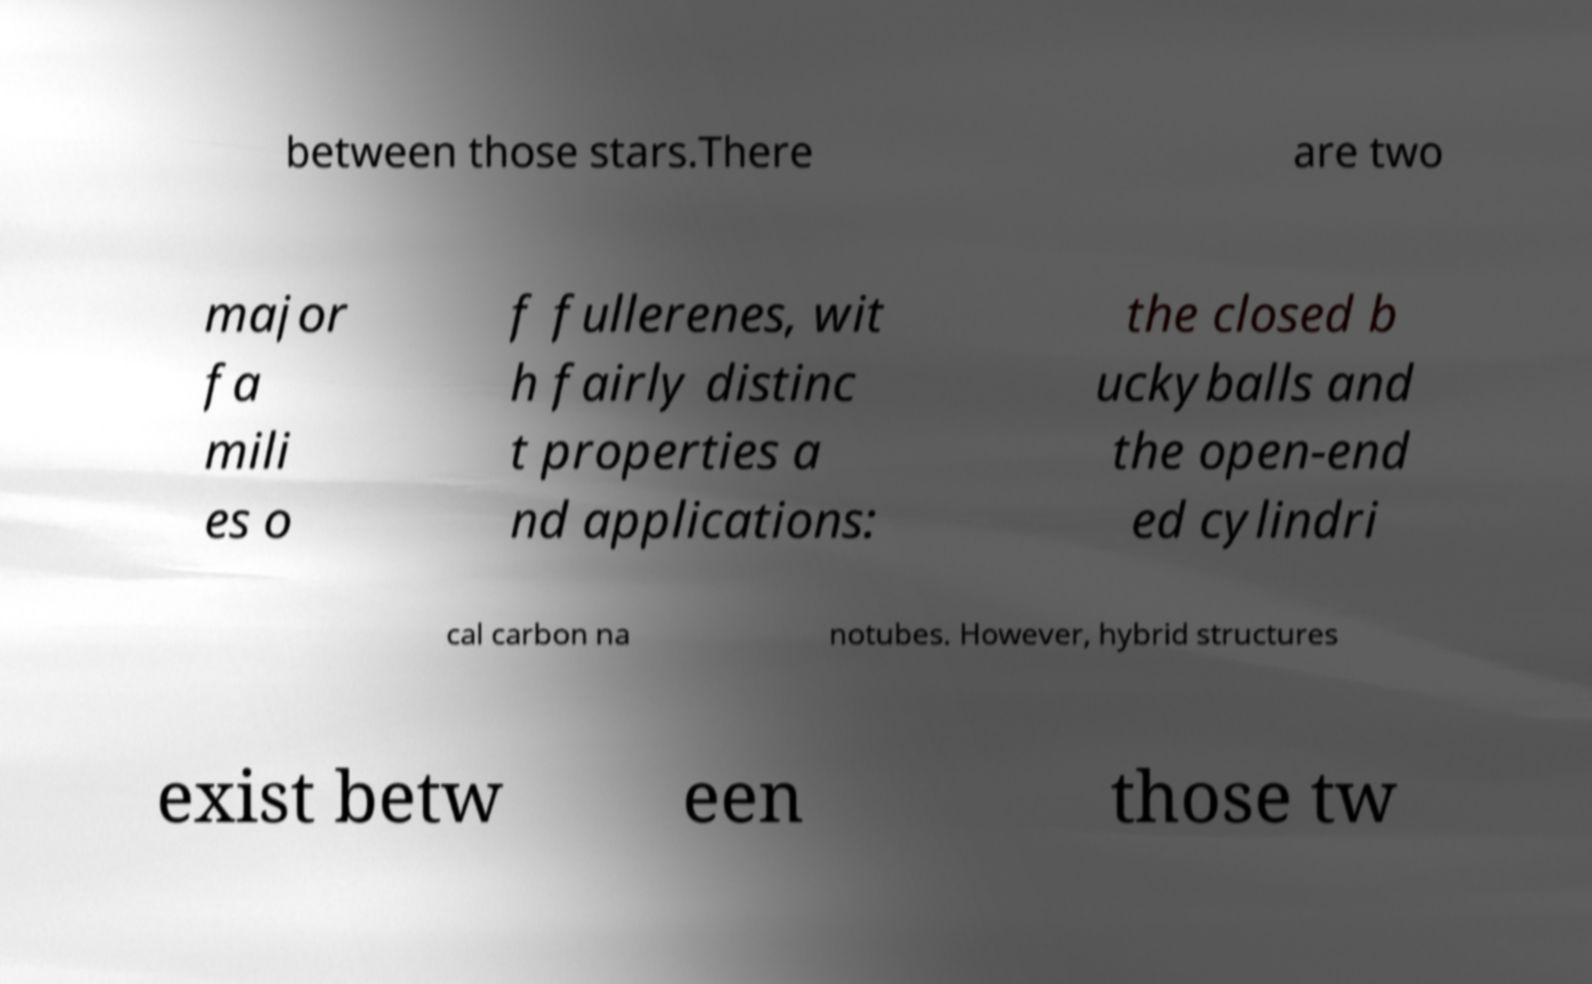Please read and relay the text visible in this image. What does it say? between those stars.There are two major fa mili es o f fullerenes, wit h fairly distinc t properties a nd applications: the closed b uckyballs and the open-end ed cylindri cal carbon na notubes. However, hybrid structures exist betw een those tw 